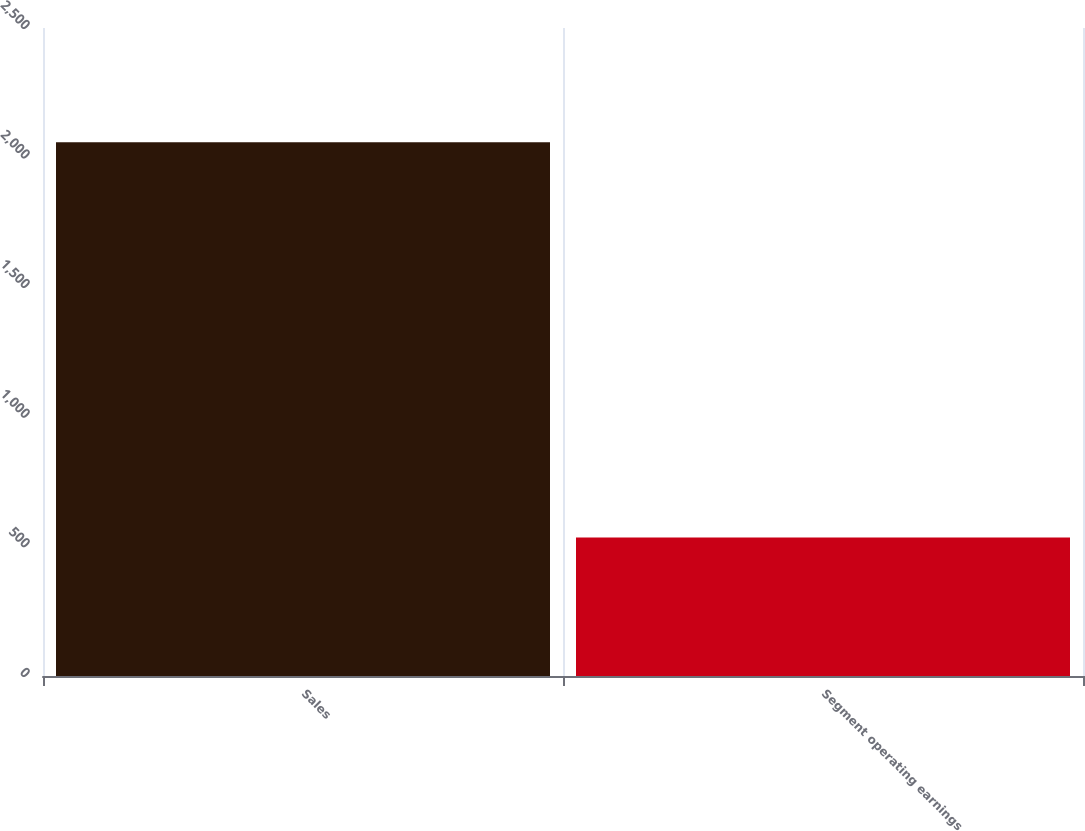Convert chart to OTSL. <chart><loc_0><loc_0><loc_500><loc_500><bar_chart><fcel>Sales<fcel>Segment operating earnings<nl><fcel>2059.2<fcel>533.9<nl></chart> 